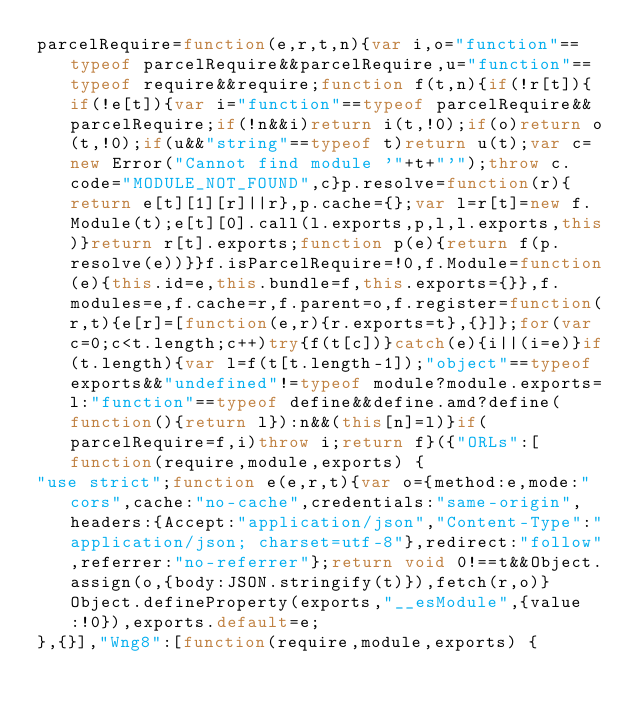<code> <loc_0><loc_0><loc_500><loc_500><_JavaScript_>parcelRequire=function(e,r,t,n){var i,o="function"==typeof parcelRequire&&parcelRequire,u="function"==typeof require&&require;function f(t,n){if(!r[t]){if(!e[t]){var i="function"==typeof parcelRequire&&parcelRequire;if(!n&&i)return i(t,!0);if(o)return o(t,!0);if(u&&"string"==typeof t)return u(t);var c=new Error("Cannot find module '"+t+"'");throw c.code="MODULE_NOT_FOUND",c}p.resolve=function(r){return e[t][1][r]||r},p.cache={};var l=r[t]=new f.Module(t);e[t][0].call(l.exports,p,l,l.exports,this)}return r[t].exports;function p(e){return f(p.resolve(e))}}f.isParcelRequire=!0,f.Module=function(e){this.id=e,this.bundle=f,this.exports={}},f.modules=e,f.cache=r,f.parent=o,f.register=function(r,t){e[r]=[function(e,r){r.exports=t},{}]};for(var c=0;c<t.length;c++)try{f(t[c])}catch(e){i||(i=e)}if(t.length){var l=f(t[t.length-1]);"object"==typeof exports&&"undefined"!=typeof module?module.exports=l:"function"==typeof define&&define.amd?define(function(){return l}):n&&(this[n]=l)}if(parcelRequire=f,i)throw i;return f}({"ORLs":[function(require,module,exports) {
"use strict";function e(e,r,t){var o={method:e,mode:"cors",cache:"no-cache",credentials:"same-origin",headers:{Accept:"application/json","Content-Type":"application/json; charset=utf-8"},redirect:"follow",referrer:"no-referrer"};return void 0!==t&&Object.assign(o,{body:JSON.stringify(t)}),fetch(r,o)}Object.defineProperty(exports,"__esModule",{value:!0}),exports.default=e;
},{}],"Wng8":[function(require,module,exports) {</code> 